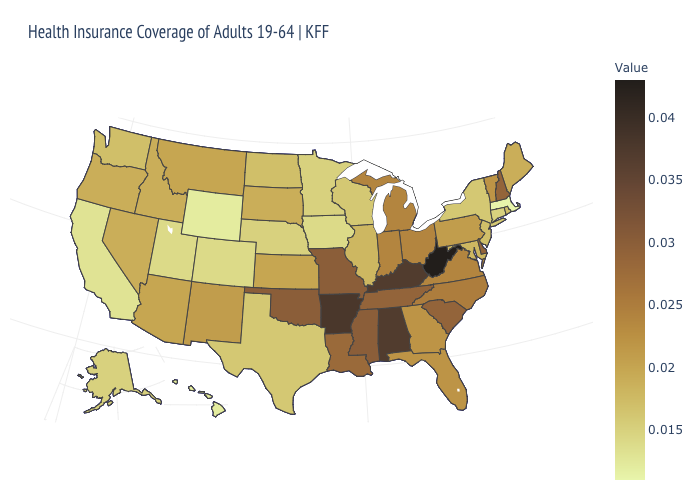Does Connecticut have a lower value than Massachusetts?
Write a very short answer. No. Is the legend a continuous bar?
Short answer required. Yes. Which states have the lowest value in the USA?
Answer briefly. Massachusetts. Does Missouri have the highest value in the MidWest?
Be succinct. Yes. Among the states that border Oklahoma , which have the lowest value?
Write a very short answer. Colorado. 